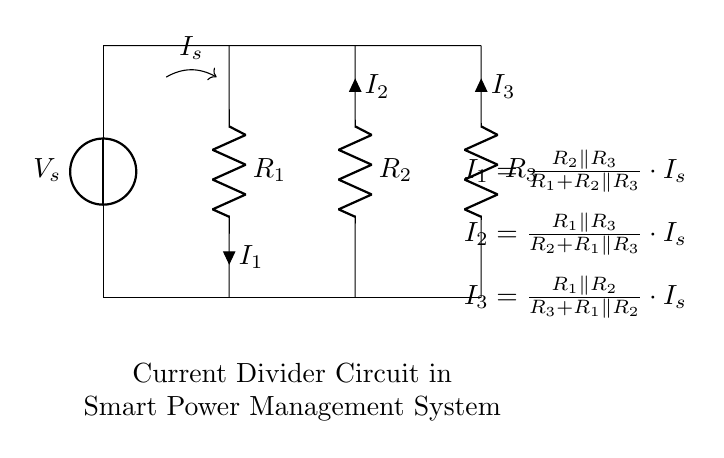What is the source voltage in the circuit? The voltage source labeled as V_s indicates the input voltage for this circuit. It is the potential difference provided, but its actual value is not specified in the diagram.
Answer: V_s What are the resistance values in this circuit? The resistances are labeled as R_1, R_2, and R_3. The actual values are not provided in the diagram, but they represent the components in the current divider.
Answer: R_1, R_2, R_3 What is the total current entering the circuit? The total current entering the circuit is indicated by I_s as shown in the diagram, which is the current supplied by the voltage source.
Answer: I_s How many currents are present in the circuit? The circuit shows three distinct currents, I_1, I_2, and I_3, flowing through respective resistors. This indicates the current distribution via the current divider.
Answer: Three Which resistor directly affects the current I_1? R_2 and R_3 interact through a parallel arrangement to influence the current I_1. The current flowing through R_1 is determined by the total resistance and their configuration in the current divider.
Answer: R_2, R_3 